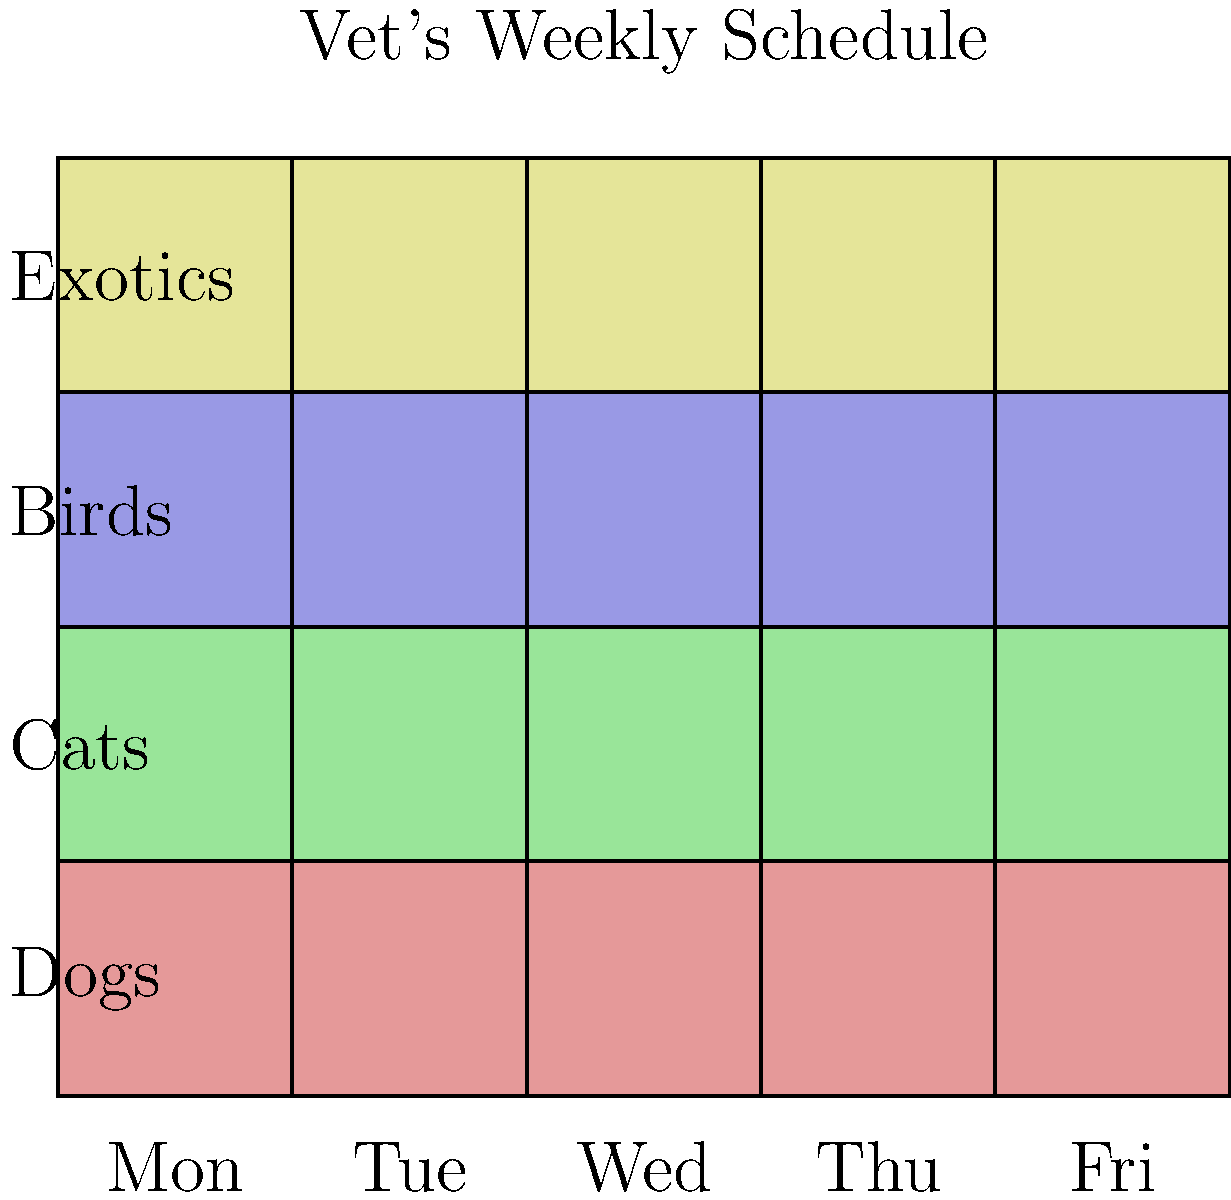Based on the vet's weekly schedule shown above, which type of animal does the vet seem to have the most experience with, and on which day would be best to schedule an appointment for a senior dog? To answer this question, we need to analyze the color-coded weekly schedule:

1. First, let's identify what each color represents:
   - Red: Dogs
   - Green: Cats
   - Blue: Birds
   - Yellow: Exotic animals

2. To determine which animal the vet has the most experience with, we need to count the number of slots for each animal type:
   - Dogs (Red): 5 slots
   - Cats (Green): 5 slots
   - Birds (Blue): 5 slots
   - Exotic animals (Yellow): 5 slots

   The vet has an equal number of slots for all animal types, indicating balanced experience across all categories.

3. To find the best day to schedule an appointment for a senior dog, we should look for a day with multiple dog slots, preferably at the beginning of the week when the vet might be less tired:
   - Monday: 1 dog slot
   - Tuesday: 2 dog slots
   - Wednesday: 1 dog slot
   - Thursday: 0 dog slots
   - Friday: 1 dog slot

   Tuesday has the most dog slots (2) and is early in the week, making it the best choice for scheduling a senior dog appointment.
Answer: Equal experience with all animals; Tuesday for senior dog appointment 